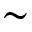Convert formula to latex. <formula><loc_0><loc_0><loc_500><loc_500>\sim</formula> 